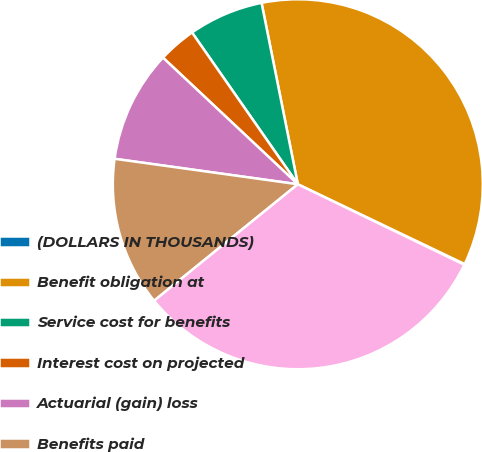Convert chart. <chart><loc_0><loc_0><loc_500><loc_500><pie_chart><fcel>(DOLLARS IN THOUSANDS)<fcel>Benefit obligation at<fcel>Service cost for benefits<fcel>Interest cost on projected<fcel>Actuarial (gain) loss<fcel>Benefits paid<fcel>Benefit obligation at end of<nl><fcel>0.07%<fcel>35.24%<fcel>6.55%<fcel>3.31%<fcel>9.8%<fcel>13.04%<fcel>31.99%<nl></chart> 